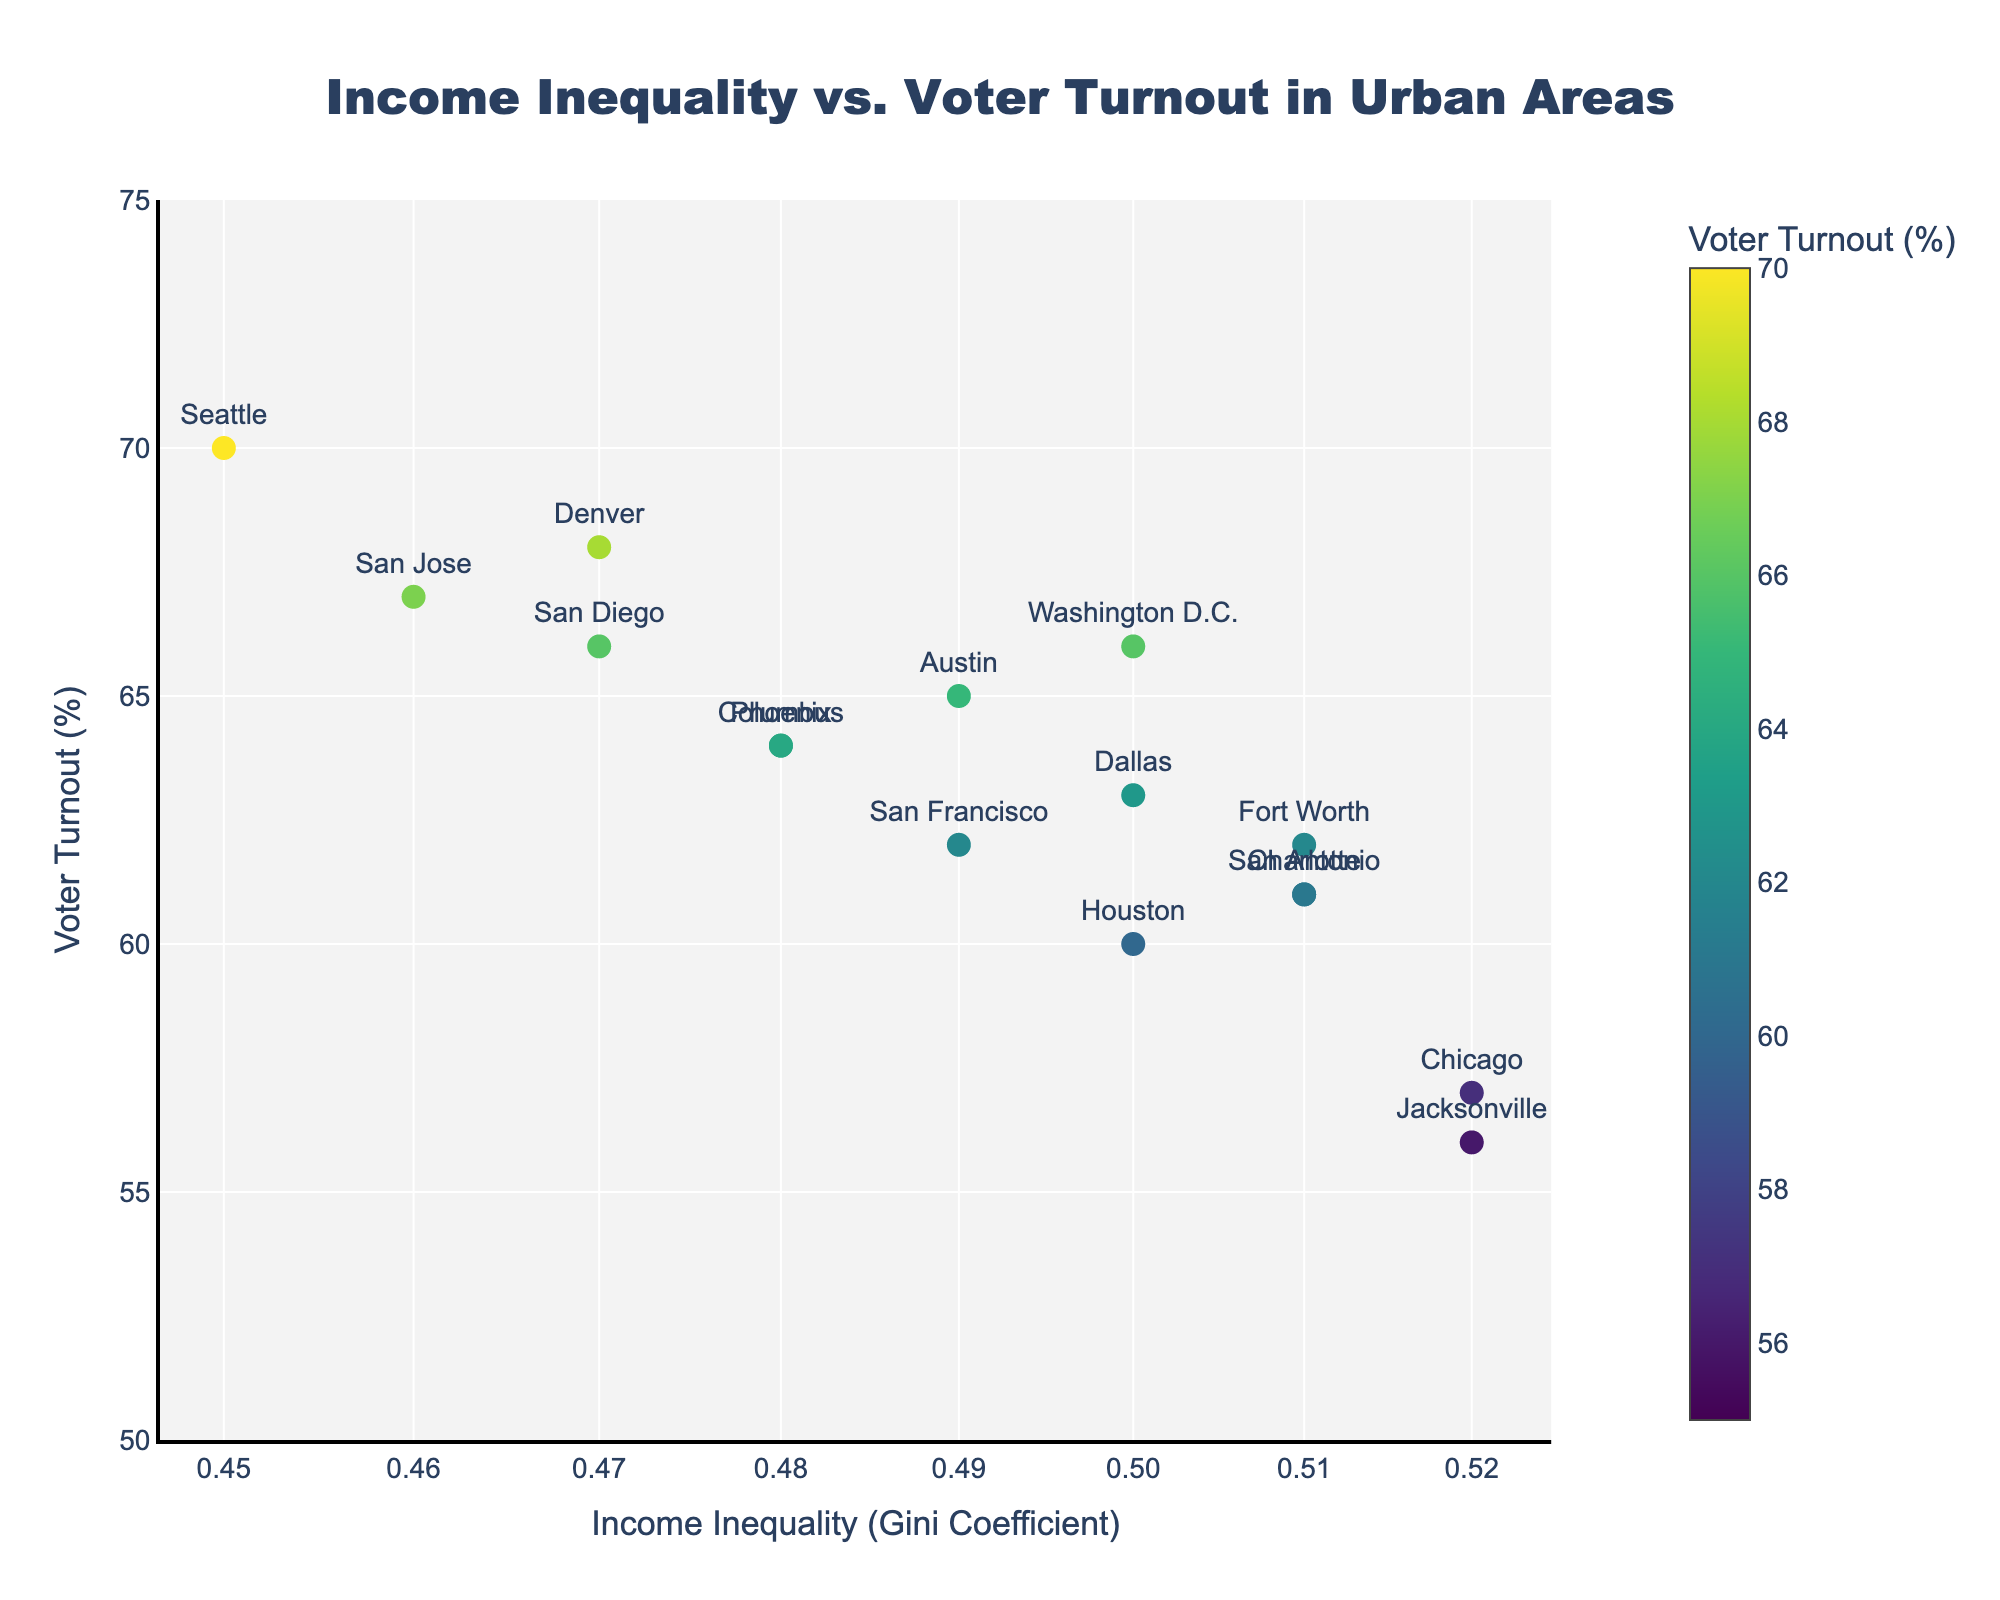What is the title of the scatter plot? The title is located at the top of the scatter plot, which provides a summary of what the plot is about.
Answer: Income Inequality vs. Voter Turnout in Urban Areas What is the color bar representing in the scatter plot? The color bar next to the scatter plot indicates the range of voter turnout percentages corresponding to the colors of the markers.
Answer: Voter Turnout (%) Which urban area has the highest voter turnout? By examining the plot and identifying the marker labeled with the highest voter turnout percentage, we find the urban area.
Answer: Seattle What is the approximate voter turnout percentage for urban areas with an income inequality (Gini Coefficient) of about 0.50? We locate markers around the x-axis value of 0.50 and note their corresponding y-axis values (voter turnout percentages).
Answer: Approximately 60-66% How many urban areas have a voter turnout greater than 65%? Count the markers positioned above the 65% line on the y-axis.
Answer: 3 Which urban area has a Gini Coefficient closest to 0.46? Find the marker closest to the x-axis value of 0.46 and check its label for the urban area name.
Answer: San Jose Is there a general trend between income inequality and voter turnout in this scatter plot? Observe the overall distribution of markers to identify if there is a noticeable positive, negative, or no correlation trend between x and y values.
Answer: No clear trend What is the voter turnout percentage for Chicago? Find the marker labeled as Chicago and note its corresponding y-axis value.
Answer: 57% Is there any urban area with a Gini Coefficient of 0.45? Look for a marker placed exactly at the x-axis value of 0.45 and identify if it exists.
Answer: No Which urban area has similar voter turnout and income inequality to Los Angeles? Locate Los Angeles' marker and identify nearby markers with similar x and y values, and then check their labels.
Answer: Indianapolis 